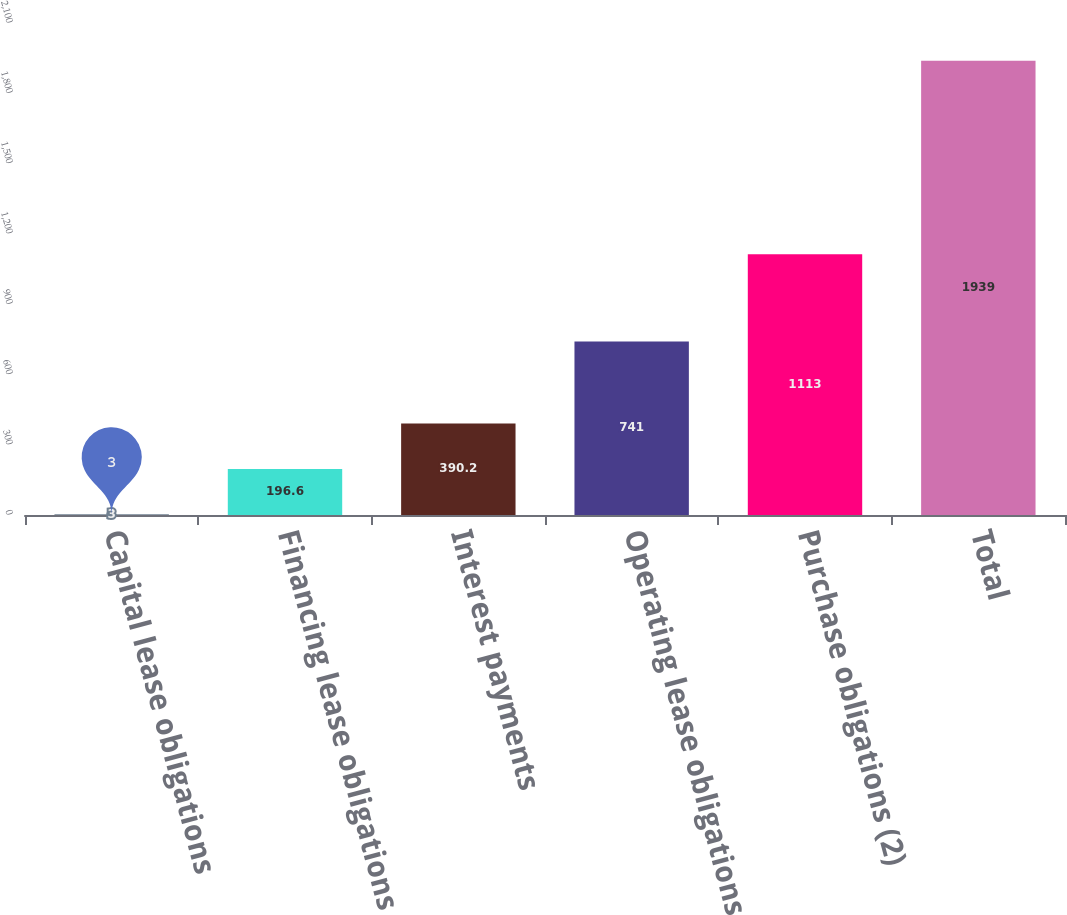Convert chart. <chart><loc_0><loc_0><loc_500><loc_500><bar_chart><fcel>Capital lease obligations<fcel>Financing lease obligations<fcel>Interest payments<fcel>Operating lease obligations<fcel>Purchase obligations (2)<fcel>Total<nl><fcel>3<fcel>196.6<fcel>390.2<fcel>741<fcel>1113<fcel>1939<nl></chart> 